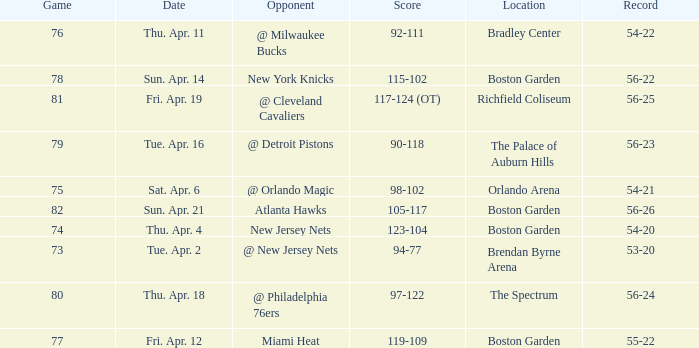Which Score has a Location of richfield coliseum? 117-124 (OT). 